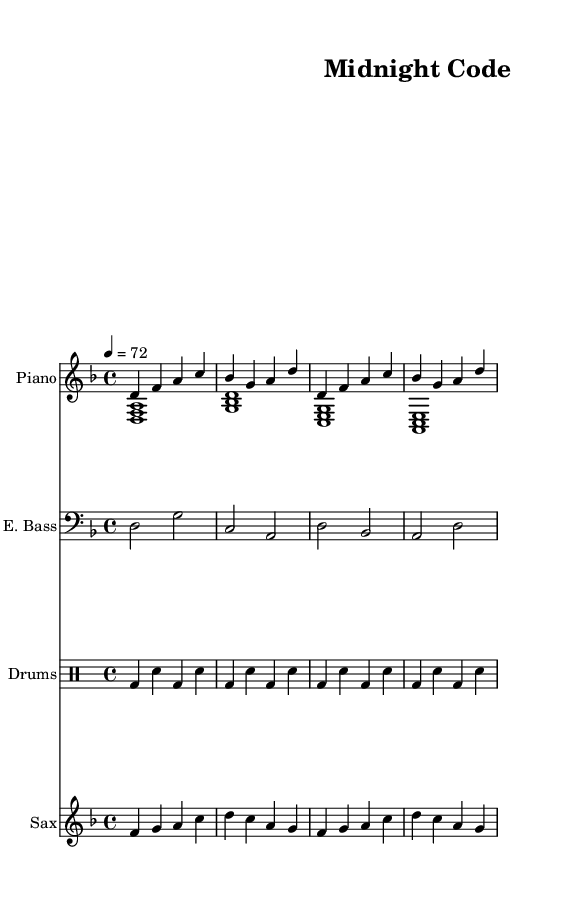What is the key signature of this music? The key signature is D minor, which has one flat (B flat). This can be identified from the two flat symbols at the start of the staff, indicating D minor.
Answer: D minor What is the time signature of this music? The time signature is 4/4, which is shown at the beginning of the score. This indicates four beats per measure, with the quarter note receiving one beat.
Answer: 4/4 What is the tempo marking for this piece? The tempo marking is 72 beats per minute, indicated at the beginning as "4 = 72". This tells the performer the speed at which to play the piece.
Answer: 72 Which instrument has the melody in this arrangement? The melody is primarily played by the saxophone, identifiable as it often carries the main thematic lines in this style and is placed in a separate staff.
Answer: Saxophone How many measures are in the piano part? The piano part consists of 4 measures, which can be counted by examining the vertical lines that separate each measure in the staff.
Answer: 4 Identify the type of music this score represents. This score represents smooth jazz-influenced R&B, as indicated by the combination of jazz chords, grooves, and instrumentation typical of R&B music styles. This is evident from the instruments used and the overall style of the arrangement.
Answer: R&B 